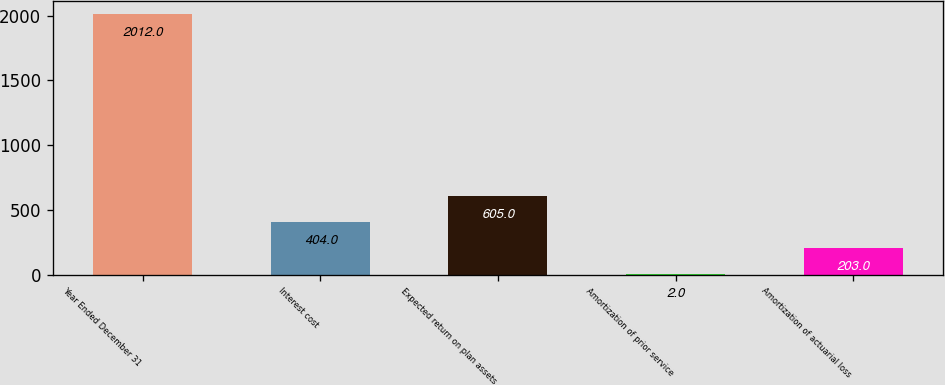<chart> <loc_0><loc_0><loc_500><loc_500><bar_chart><fcel>Year Ended December 31<fcel>Interest cost<fcel>Expected return on plan assets<fcel>Amortization of prior service<fcel>Amortization of actuarial loss<nl><fcel>2012<fcel>404<fcel>605<fcel>2<fcel>203<nl></chart> 